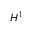<formula> <loc_0><loc_0><loc_500><loc_500>H ^ { 1 }</formula> 